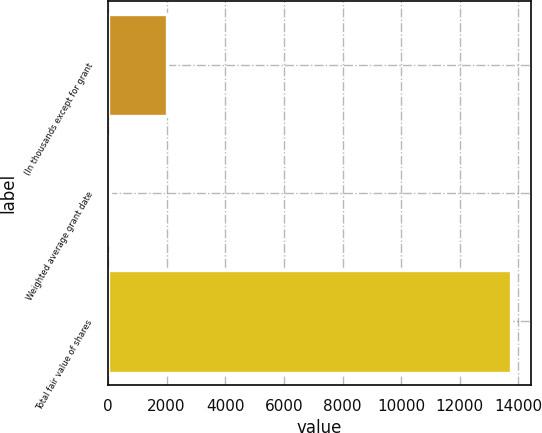Convert chart to OTSL. <chart><loc_0><loc_0><loc_500><loc_500><bar_chart><fcel>(In thousands except for grant<fcel>Weighted average grant date<fcel>Total fair value of shares<nl><fcel>2015<fcel>68.57<fcel>13730<nl></chart> 